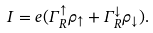<formula> <loc_0><loc_0><loc_500><loc_500>I = e ( \Gamma _ { R } ^ { \uparrow } \rho _ { \uparrow } + \Gamma _ { R } ^ { \downarrow } \rho _ { \downarrow } ) .</formula> 